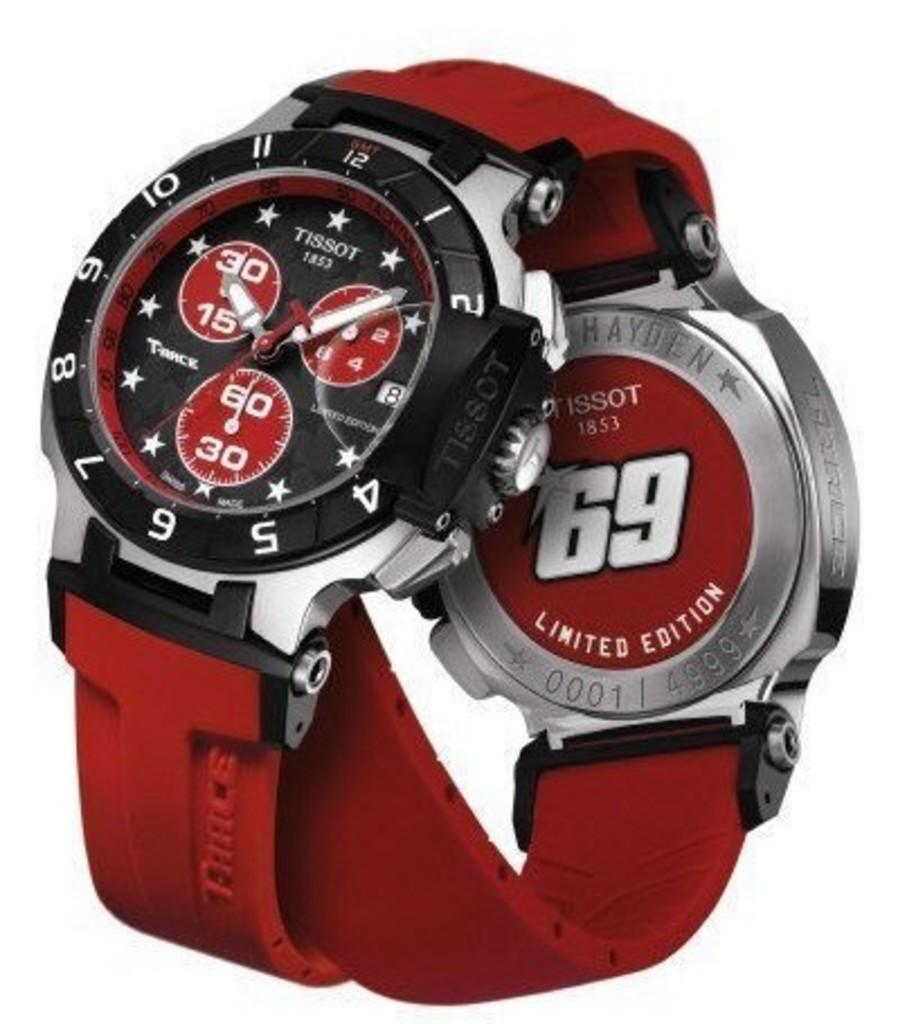Provide a one-sentence caption for the provided image. A limited edition Tissot watch is albeled with the number 69 on the back of it. 